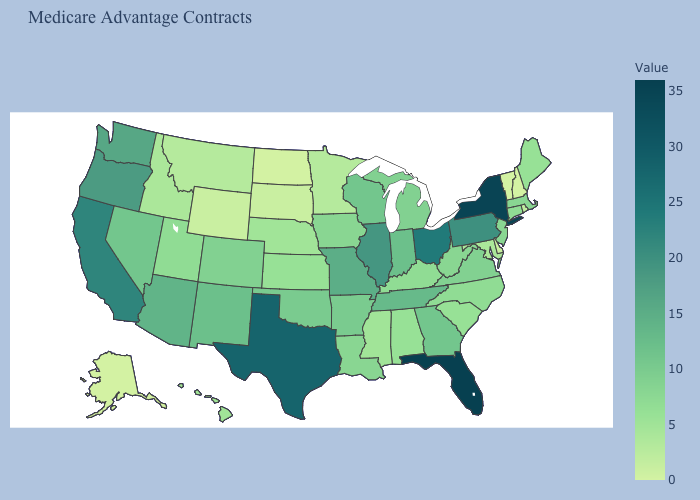Does Florida have the highest value in the South?
Quick response, please. Yes. Which states have the lowest value in the USA?
Short answer required. Alaska, North Dakota, New Hampshire, Vermont. Among the states that border South Dakota , does Minnesota have the highest value?
Keep it brief. No. 